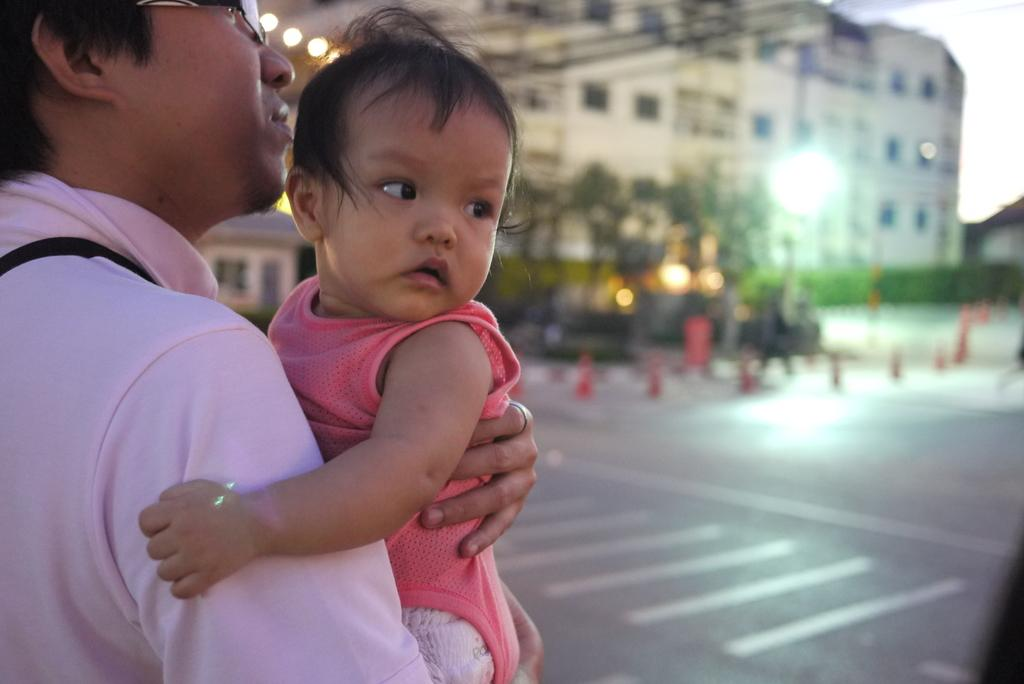Where was the image taken? The image was clicked outside. What can be seen at the top of the image? There is a building at the top of the image. What is the man on the left side of the image doing? The man is holding a baby in his hands. What type of company is the man working for in the image? There is no indication of a company or any work-related context in the image. Can you tell me how many pockets the baby has in the image? The baby does not have any visible pockets in the image. 